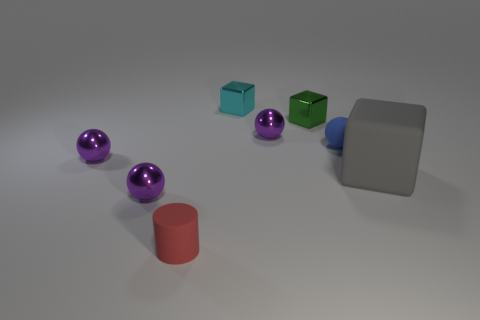Subtract all purple spheres. How many were subtracted if there are1purple spheres left? 2 Subtract all blue spheres. How many spheres are left? 3 Subtract all blue spheres. How many spheres are left? 3 Add 1 green things. How many objects exist? 9 Subtract all cubes. How many objects are left? 5 Subtract all purple blocks. Subtract all yellow balls. How many blocks are left? 3 Subtract all cyan cylinders. How many blue cubes are left? 0 Subtract all large gray metallic objects. Subtract all small blue things. How many objects are left? 7 Add 3 cylinders. How many cylinders are left? 4 Add 5 small red objects. How many small red objects exist? 6 